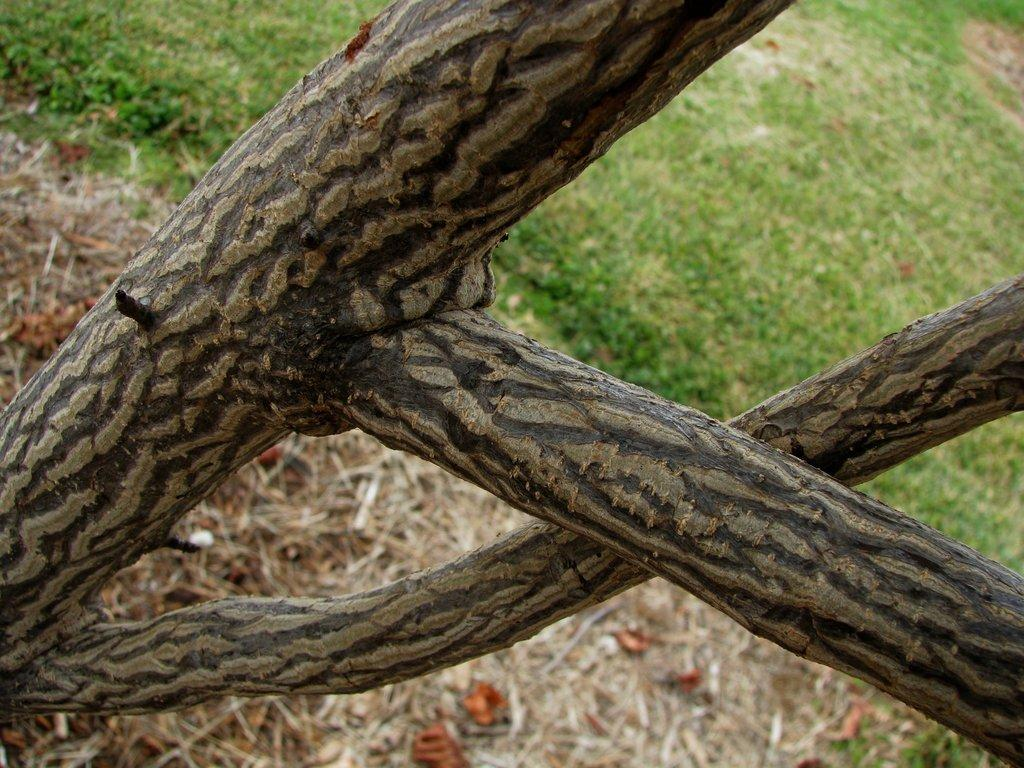What is located in the front of the image? There is a plant in the front of the image. What type of vegetation can be seen in the background of the image? There is grass and leaves in the background of the image. How many apples are hanging from the plant in the image? There are no apples present in the image; it only features a plant, grass, and leaves. Is there a ring visible on any of the leaves in the image? There is no ring present in the image; it only features a plant, grass, and leaves. 